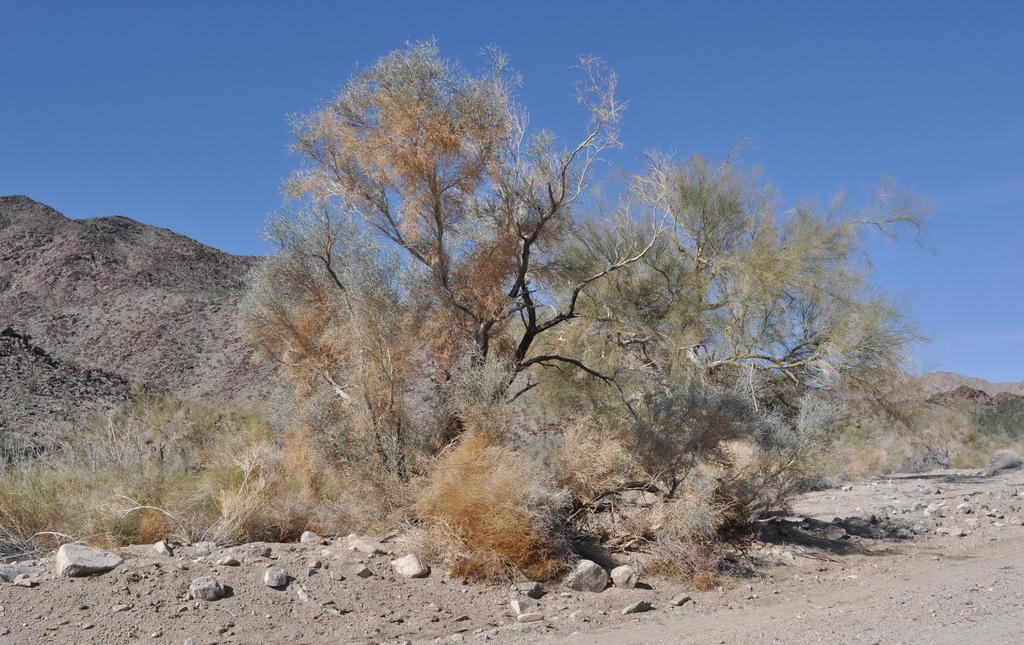What type of natural elements can be seen in the image? There are stones, trees, and hills visible in the image. What is visible in the background of the image? The sky is visible in the image. What type of bells can be heard ringing in the image? There are no bells present in the image, and therefore no sound can be heard. 